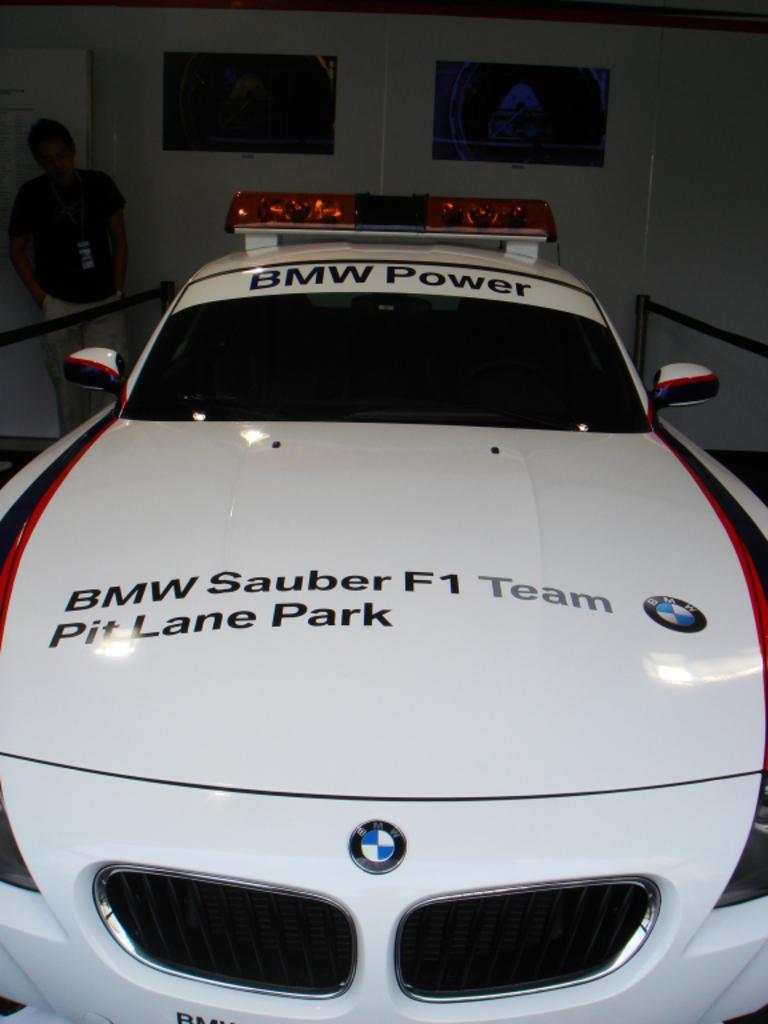Can you describe this image briefly? In this image in the front there is a car with some text written on it. In the background there are posters on the wall and there is a person standing and there is a fence on both side of the car. 